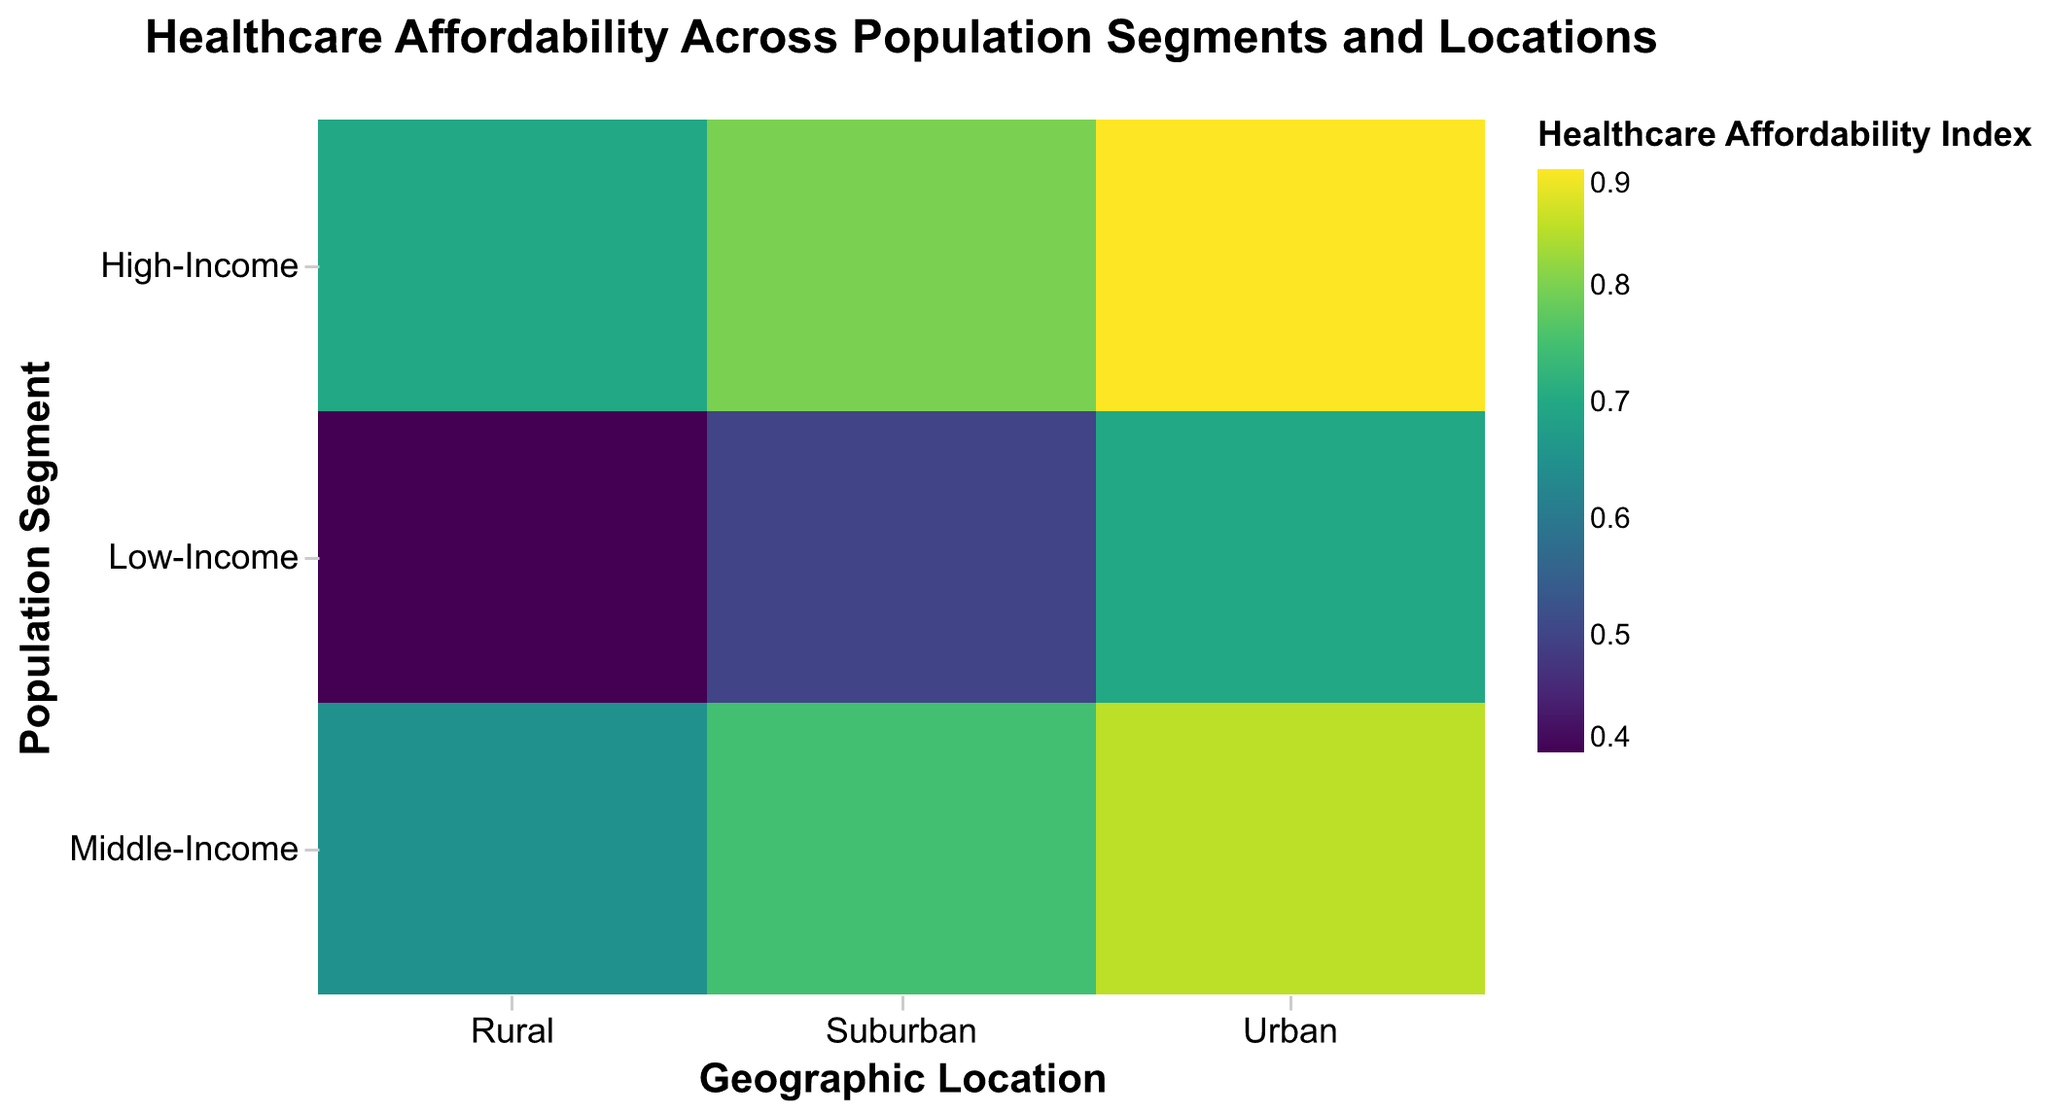what is the title of the plot? The title is typically located at the top of the figure, providing a summary of what the plot is about. Here, the title reads "Healthcare Affordability Across Population Segments and Locations"
Answer: Healthcare Affordability Across Population Segments and Locations Which population segment and geographic location has the highest healthcare affordability index? To find the highest healthcare affordability index, look at the heatmap and identify the darkest color. In this case, the "High-Income, Urban" segment has the highest index of 0.9.
Answer: High-Income, Urban How does the travel distance to the nearest hospital compare between Low-Income Rural areas and Middle-Income Suburban areas? The Low-Income Rural areas have a travel distance of 25 miles to the nearest hospital, whereas Middle-Income Suburban areas have a travel distance of 5 miles.
Answer: Low-Income Rural: 25 miles, Middle-Income Suburban: 5 miles What can you infer about the access to primary care physicians in urban areas across different income segments? By looking at the primary care access percentages in urban areas for Low-Income (85%), Middle-Income (90%), and High-Income (95%), we can infer that access increases with income level.
Answer: Access increases with income level Is there a notable difference in healthcare affordability between High-Income and Low-Income segments in suburban areas? Yes, comparing the healthcare affordability indices, it's 0.8 for High-Income and 0.5 for Low-Income. The difference is 0.3, indicating higher affordability for High-Income segments in suburban areas.
Answer: Yes, difference of 0.3 Which subgroup has the lowest insurance coverage, and what is that coverage percentage? The Low-Income Rural subgroup has the lowest insurance coverage at 30%. This can be observed by looking at the percentage across all segments and locations.
Answer: Low-Income Rural, 30% Compare the access to specialized medical services in rural areas across different income segments. In rural areas, Low-Income has 30%, Middle-Income has 50%, and High-Income has 70%. There is a steady increase in access to specialized medical services with higher income levels.
Answer: Access increases with income level What is the correlation between healthcare affordability and geographic location within the High-Income segment? By analyzing the healthcare affordability indices for High-Income across Urban (0.9), Suburban (0.8), and Rural (0.7), we see a decreasing trend in affordability as geographic location moves from Urban to Rural.
Answer: Decreasing trend from Urban to Rural 